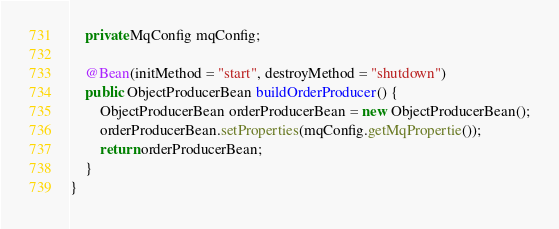Convert code to text. <code><loc_0><loc_0><loc_500><loc_500><_Java_>    private MqConfig mqConfig;

    @Bean(initMethod = "start", destroyMethod = "shutdown")
    public ObjectProducerBean buildOrderProducer() {
        ObjectProducerBean orderProducerBean = new ObjectProducerBean();
        orderProducerBean.setProperties(mqConfig.getMqPropertie());
        return orderProducerBean;
    }
}
</code> 